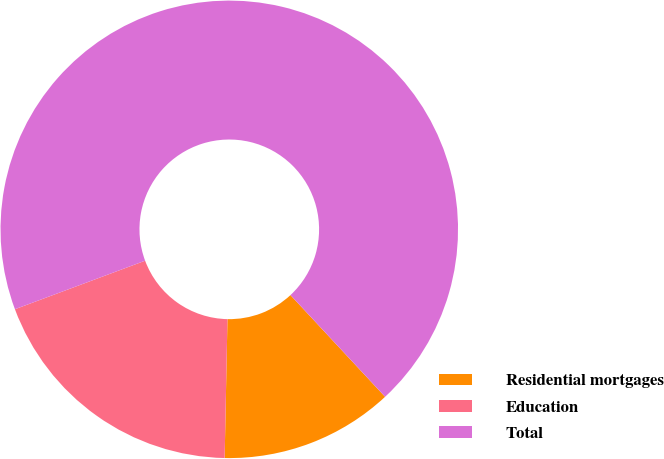Convert chart. <chart><loc_0><loc_0><loc_500><loc_500><pie_chart><fcel>Residential mortgages<fcel>Education<fcel>Total<nl><fcel>12.25%<fcel>19.0%<fcel>68.75%<nl></chart> 